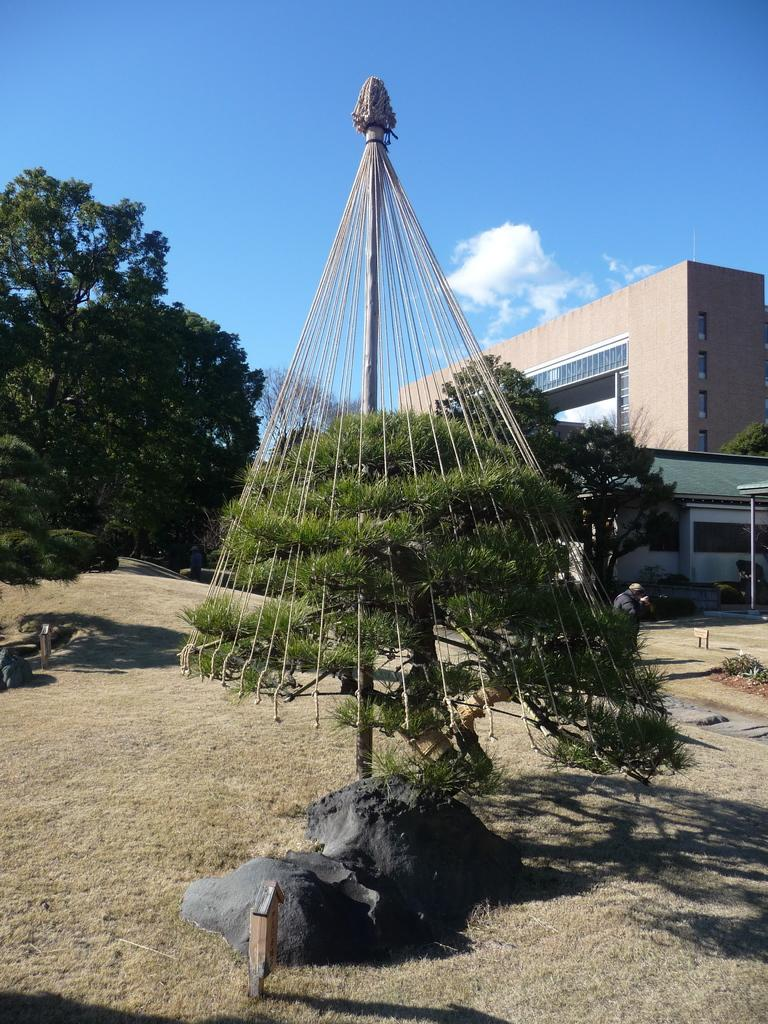What object is on the ground in the image? There is an umbrella on the ground in the image. What can be seen in the background of the image? There are buildings and trees visible in the background of the image. What type of pancake is being eaten by the mouth in the image? There is no pancake or mouth present in the image. 